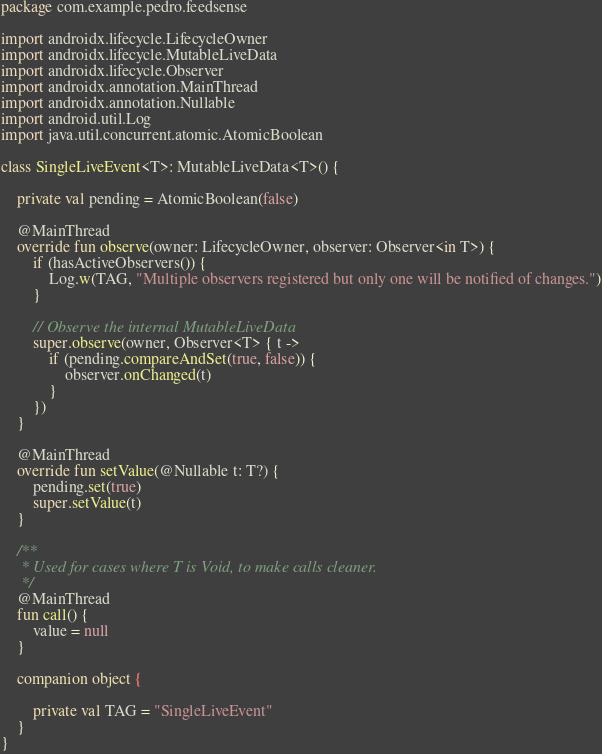<code> <loc_0><loc_0><loc_500><loc_500><_Kotlin_>package com.example.pedro.feedsense

import androidx.lifecycle.LifecycleOwner
import androidx.lifecycle.MutableLiveData
import androidx.lifecycle.Observer
import androidx.annotation.MainThread
import androidx.annotation.Nullable
import android.util.Log
import java.util.concurrent.atomic.AtomicBoolean

class SingleLiveEvent<T>: MutableLiveData<T>() {

    private val pending = AtomicBoolean(false)

    @MainThread
    override fun observe(owner: LifecycleOwner, observer: Observer<in T>) {
        if (hasActiveObservers()) {
            Log.w(TAG, "Multiple observers registered but only one will be notified of changes.")
        }

        // Observe the internal MutableLiveData
        super.observe(owner, Observer<T> { t ->
            if (pending.compareAndSet(true, false)) {
                observer.onChanged(t)
            }
        })
    }

    @MainThread
    override fun setValue(@Nullable t: T?) {
        pending.set(true)
        super.setValue(t)
    }

    /**
     * Used for cases where T is Void, to make calls cleaner.
     */
    @MainThread
    fun call() {
        value = null
    }

    companion object {

        private val TAG = "SingleLiveEvent"
    }
}</code> 